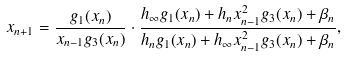Convert formula to latex. <formula><loc_0><loc_0><loc_500><loc_500>x _ { n + 1 } = \frac { g _ { 1 } ( x _ { n } ) } { x _ { n - 1 } g _ { 3 } ( x _ { n } ) } \cdot \frac { h _ { \infty } g _ { 1 } ( x _ { n } ) + h _ { n } x _ { n - 1 } ^ { 2 } g _ { 3 } ( x _ { n } ) + \beta _ { n } } { h _ { n } g _ { 1 } ( x _ { n } ) + h _ { \infty } x _ { n - 1 } ^ { 2 } g _ { 3 } ( x _ { n } ) + \beta _ { n } } ,</formula> 